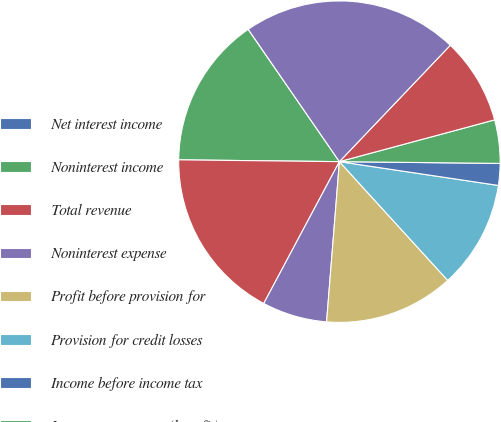<chart> <loc_0><loc_0><loc_500><loc_500><pie_chart><fcel>Net interest income<fcel>Noninterest income<fcel>Total revenue<fcel>Noninterest expense<fcel>Profit before provision for<fcel>Provision for credit losses<fcel>Income before income tax<fcel>Income tax expense (benefit)<fcel>Net income<fcel>Total average assets<nl><fcel>0.01%<fcel>15.21%<fcel>17.38%<fcel>6.53%<fcel>13.04%<fcel>10.87%<fcel>2.19%<fcel>4.36%<fcel>8.7%<fcel>21.72%<nl></chart> 